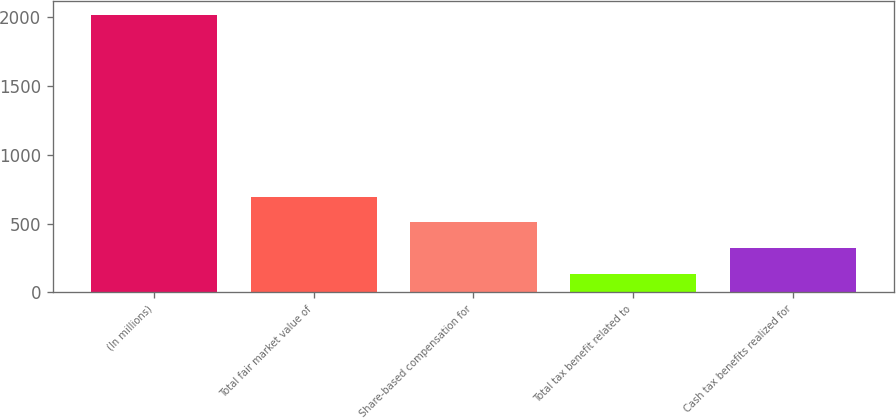Convert chart. <chart><loc_0><loc_0><loc_500><loc_500><bar_chart><fcel>(In millions)<fcel>Total fair market value of<fcel>Share-based compensation for<fcel>Total tax benefit related to<fcel>Cash tax benefits realized for<nl><fcel>2017<fcel>696.1<fcel>507.4<fcel>130<fcel>318.7<nl></chart> 